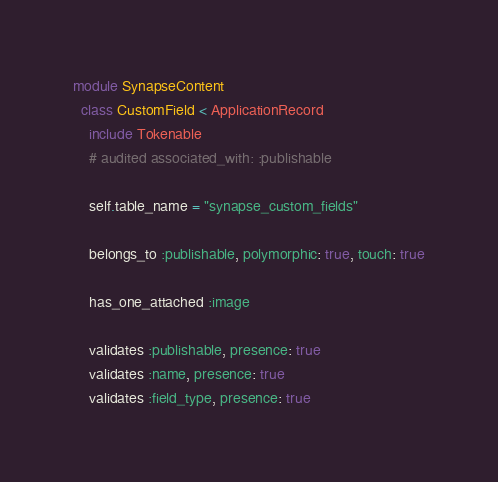<code> <loc_0><loc_0><loc_500><loc_500><_Ruby_>module SynapseContent
  class CustomField < ApplicationRecord
    include Tokenable
    # audited associated_with: :publishable

    self.table_name = "synapse_custom_fields"

    belongs_to :publishable, polymorphic: true, touch: true

    has_one_attached :image

    validates :publishable, presence: true
    validates :name, presence: true
    validates :field_type, presence: true
</code> 